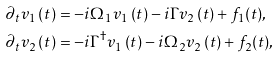<formula> <loc_0><loc_0><loc_500><loc_500>\partial _ { t } v _ { 1 } \left ( t \right ) & = - i \Omega _ { 1 } v _ { 1 } \left ( t \right ) - i \Gamma v _ { 2 } \left ( t \right ) + f _ { 1 } ( t ) , \\ \partial _ { t } v _ { 2 } \left ( t \right ) & = - i \Gamma ^ { \dagger } v _ { 1 } \left ( t \right ) - i \Omega _ { 2 } v _ { 2 } \left ( t \right ) + f _ { 2 } ( t ) ,</formula> 